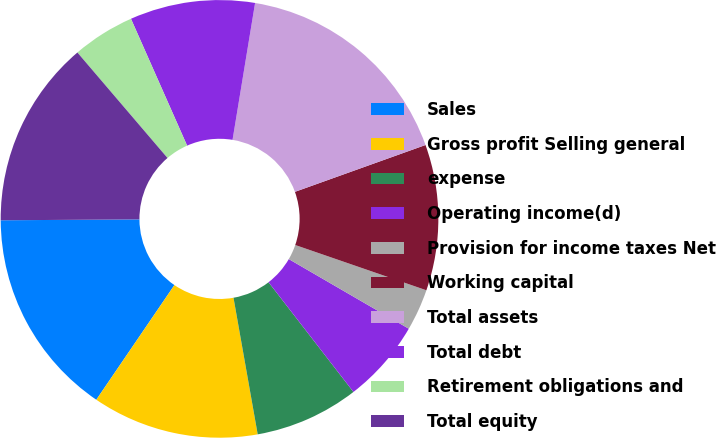<chart> <loc_0><loc_0><loc_500><loc_500><pie_chart><fcel>Sales<fcel>Gross profit Selling general<fcel>expense<fcel>Operating income(d)<fcel>Provision for income taxes Net<fcel>Working capital<fcel>Total assets<fcel>Total debt<fcel>Retirement obligations and<fcel>Total equity<nl><fcel>15.38%<fcel>12.31%<fcel>7.69%<fcel>6.15%<fcel>3.08%<fcel>10.77%<fcel>16.92%<fcel>9.23%<fcel>4.62%<fcel>13.85%<nl></chart> 